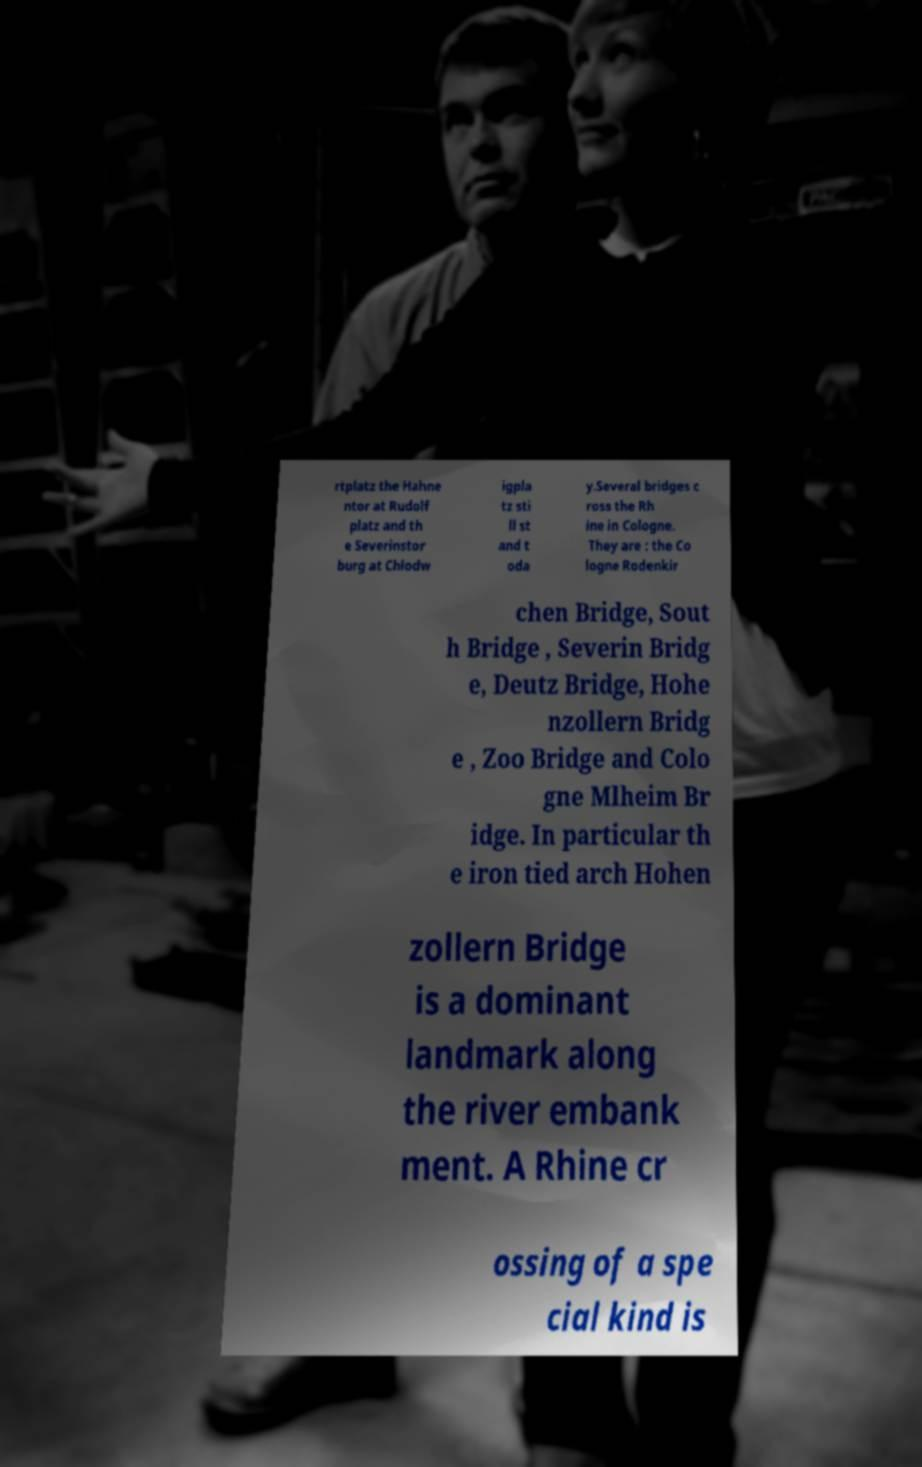For documentation purposes, I need the text within this image transcribed. Could you provide that? rtplatz the Hahne ntor at Rudolf platz and th e Severinstor burg at Chlodw igpla tz sti ll st and t oda y.Several bridges c ross the Rh ine in Cologne. They are : the Co logne Rodenkir chen Bridge, Sout h Bridge , Severin Bridg e, Deutz Bridge, Hohe nzollern Bridg e , Zoo Bridge and Colo gne Mlheim Br idge. In particular th e iron tied arch Hohen zollern Bridge is a dominant landmark along the river embank ment. A Rhine cr ossing of a spe cial kind is 